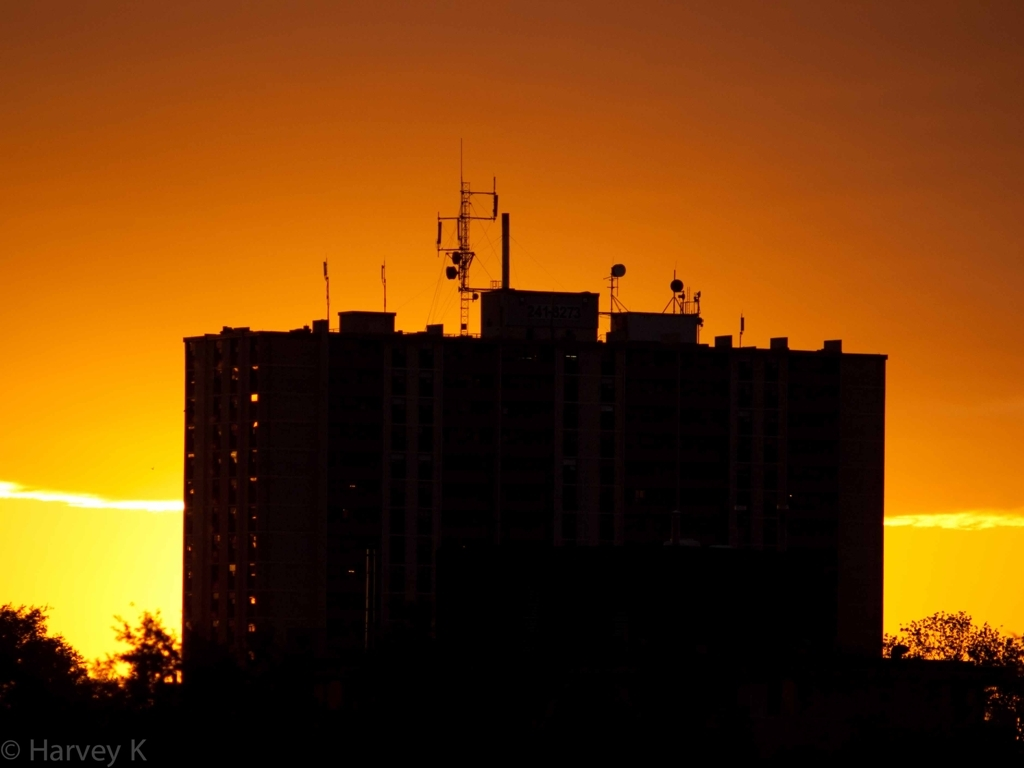Is the image of high quality? While the image may not meet high-resolution standards, it does possess an artistic quality with its striking silhouette against a vibrant sunset that captures a particular mood and moment effectively. 